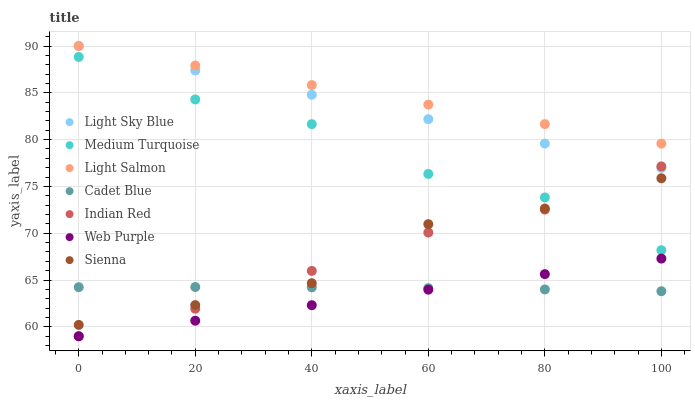Does Web Purple have the minimum area under the curve?
Answer yes or no. Yes. Does Light Salmon have the maximum area under the curve?
Answer yes or no. Yes. Does Cadet Blue have the minimum area under the curve?
Answer yes or no. No. Does Cadet Blue have the maximum area under the curve?
Answer yes or no. No. Is Light Salmon the smoothest?
Answer yes or no. Yes. Is Medium Turquoise the roughest?
Answer yes or no. Yes. Is Cadet Blue the smoothest?
Answer yes or no. No. Is Cadet Blue the roughest?
Answer yes or no. No. Does Web Purple have the lowest value?
Answer yes or no. Yes. Does Cadet Blue have the lowest value?
Answer yes or no. No. Does Light Sky Blue have the highest value?
Answer yes or no. Yes. Does Medium Turquoise have the highest value?
Answer yes or no. No. Is Indian Red less than Light Salmon?
Answer yes or no. Yes. Is Sienna greater than Web Purple?
Answer yes or no. Yes. Does Light Salmon intersect Light Sky Blue?
Answer yes or no. Yes. Is Light Salmon less than Light Sky Blue?
Answer yes or no. No. Is Light Salmon greater than Light Sky Blue?
Answer yes or no. No. Does Indian Red intersect Light Salmon?
Answer yes or no. No. 